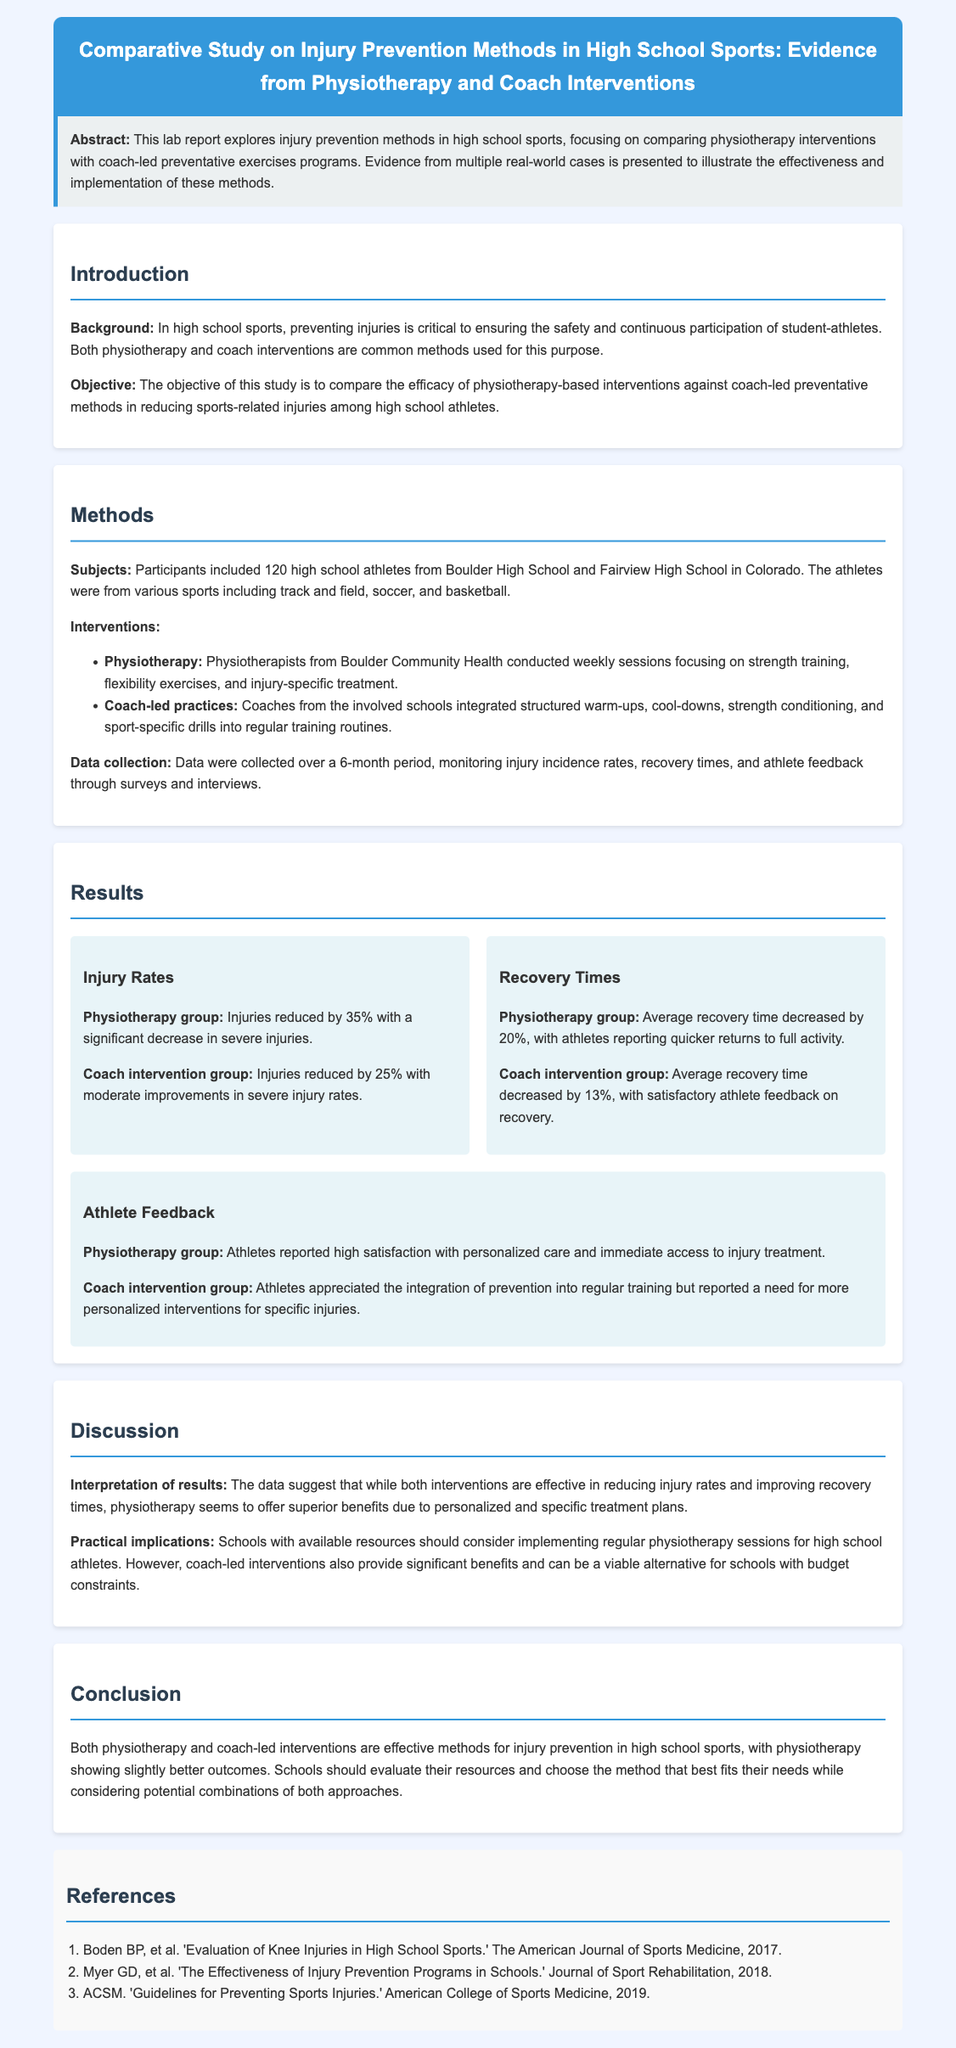What is the main focus of the lab report? The main focus of the lab report is on comparing physiotherapy interventions with coach-led preventative exercise programs for injury prevention.
Answer: Comparing physiotherapy interventions with coach-led preventative methods How many high school athletes participated in the study? The number of participants mentioned in the document is 120 high school athletes from Boulder High School and Fairview High School.
Answer: 120 By what percentage did injuries reduce in the physiotherapy group? The document states that injuries in the physiotherapy group were reduced by 35%.
Answer: 35% What intervention method had a quicker average recovery time? According to the results, the physiotherapy group had a quicker average recovery time.
Answer: Physiotherapy What do athletes in the coach intervention group appreciate about their training? The athletes in the coach intervention group appreciated the integration of prevention into regular training.
Answer: Integration of prevention into regular training What is a key recommendation for schools with available resources? Schools with available resources should consider implementing regular physiotherapy sessions.
Answer: Implementing regular physiotherapy sessions Which group showed a significant decrease in severe injuries? The physiotherapy group showed a significant decrease in severe injuries.
Answer: Physiotherapy group What type of injuries were monitored during the study? The study monitored sports-related injuries among high school athletes.
Answer: Sports-related injuries 